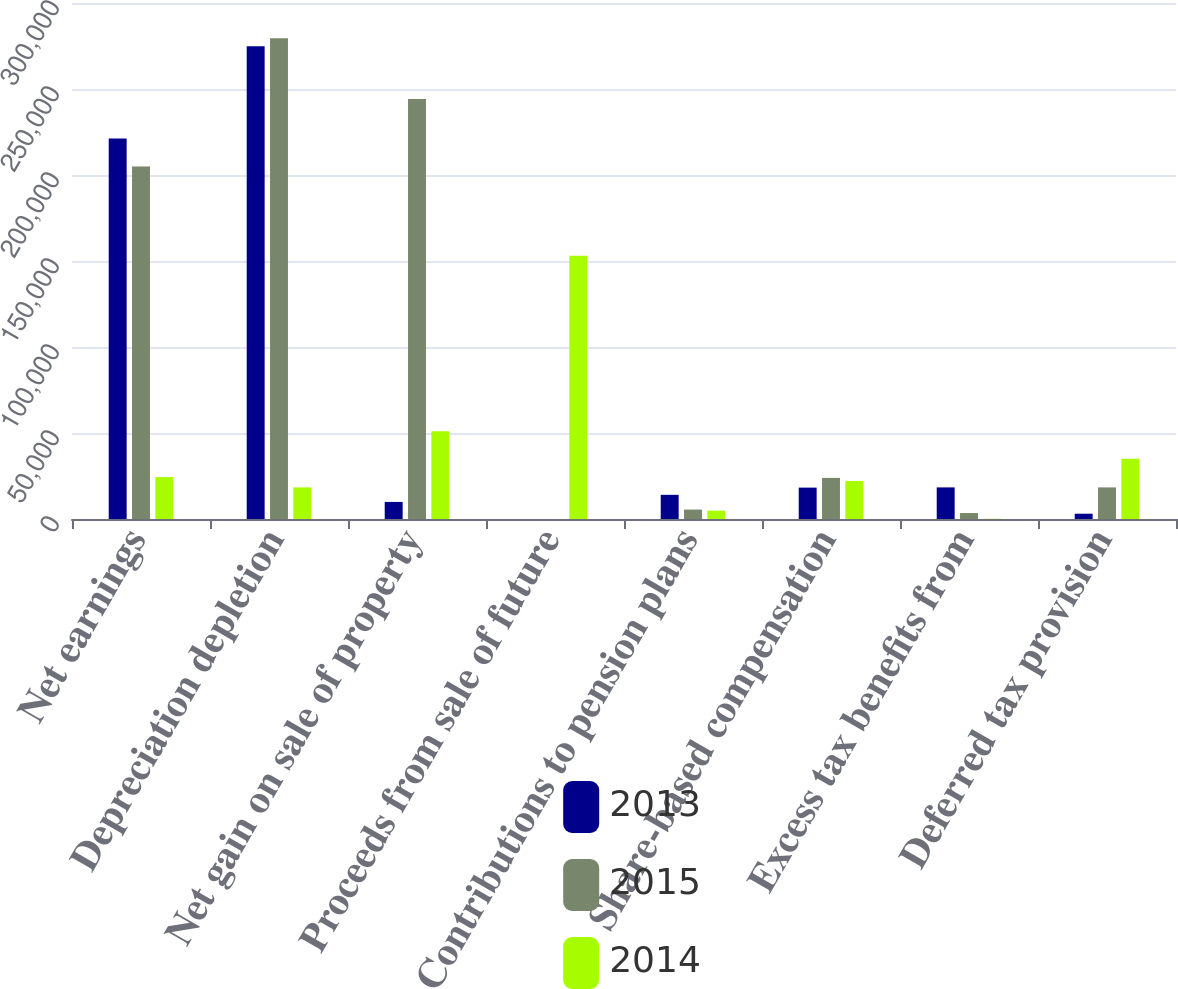<chart> <loc_0><loc_0><loc_500><loc_500><stacked_bar_chart><ecel><fcel>Net earnings<fcel>Depreciation depletion<fcel>Net gain on sale of property<fcel>Proceeds from sale of future<fcel>Contributions to pension plans<fcel>Share-based compensation<fcel>Excess tax benefits from<fcel>Deferred tax provision<nl><fcel>2013<fcel>221177<fcel>274823<fcel>9927<fcel>0<fcel>14047<fcel>18248<fcel>18376<fcel>3069<nl><fcel>2015<fcel>204923<fcel>279497<fcel>244222<fcel>0<fcel>5488<fcel>23884<fcel>3464<fcel>18378<nl><fcel>2014<fcel>24382<fcel>18378<fcel>50978<fcel>153095<fcel>4855<fcel>22093<fcel>161<fcel>35063<nl></chart> 